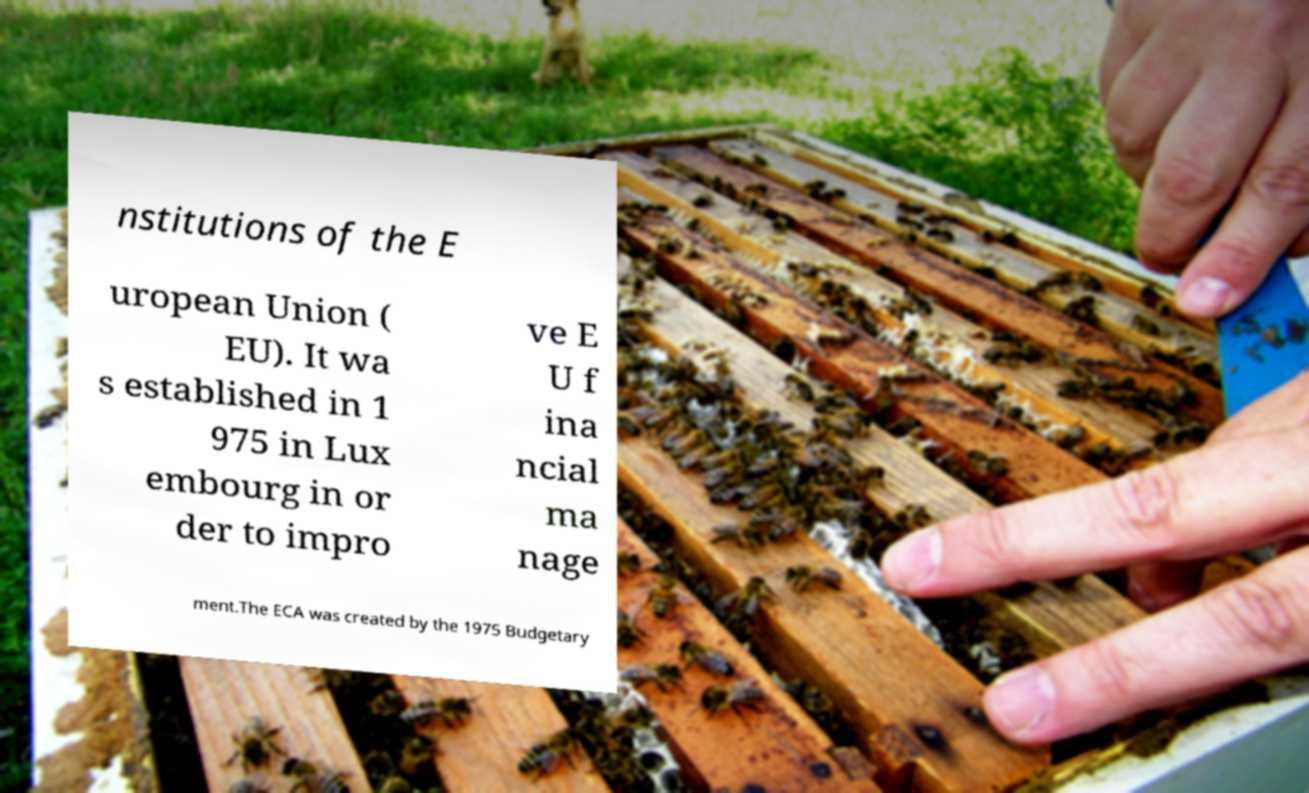Can you read and provide the text displayed in the image?This photo seems to have some interesting text. Can you extract and type it out for me? nstitutions of the E uropean Union ( EU). It wa s established in 1 975 in Lux embourg in or der to impro ve E U f ina ncial ma nage ment.The ECA was created by the 1975 Budgetary 